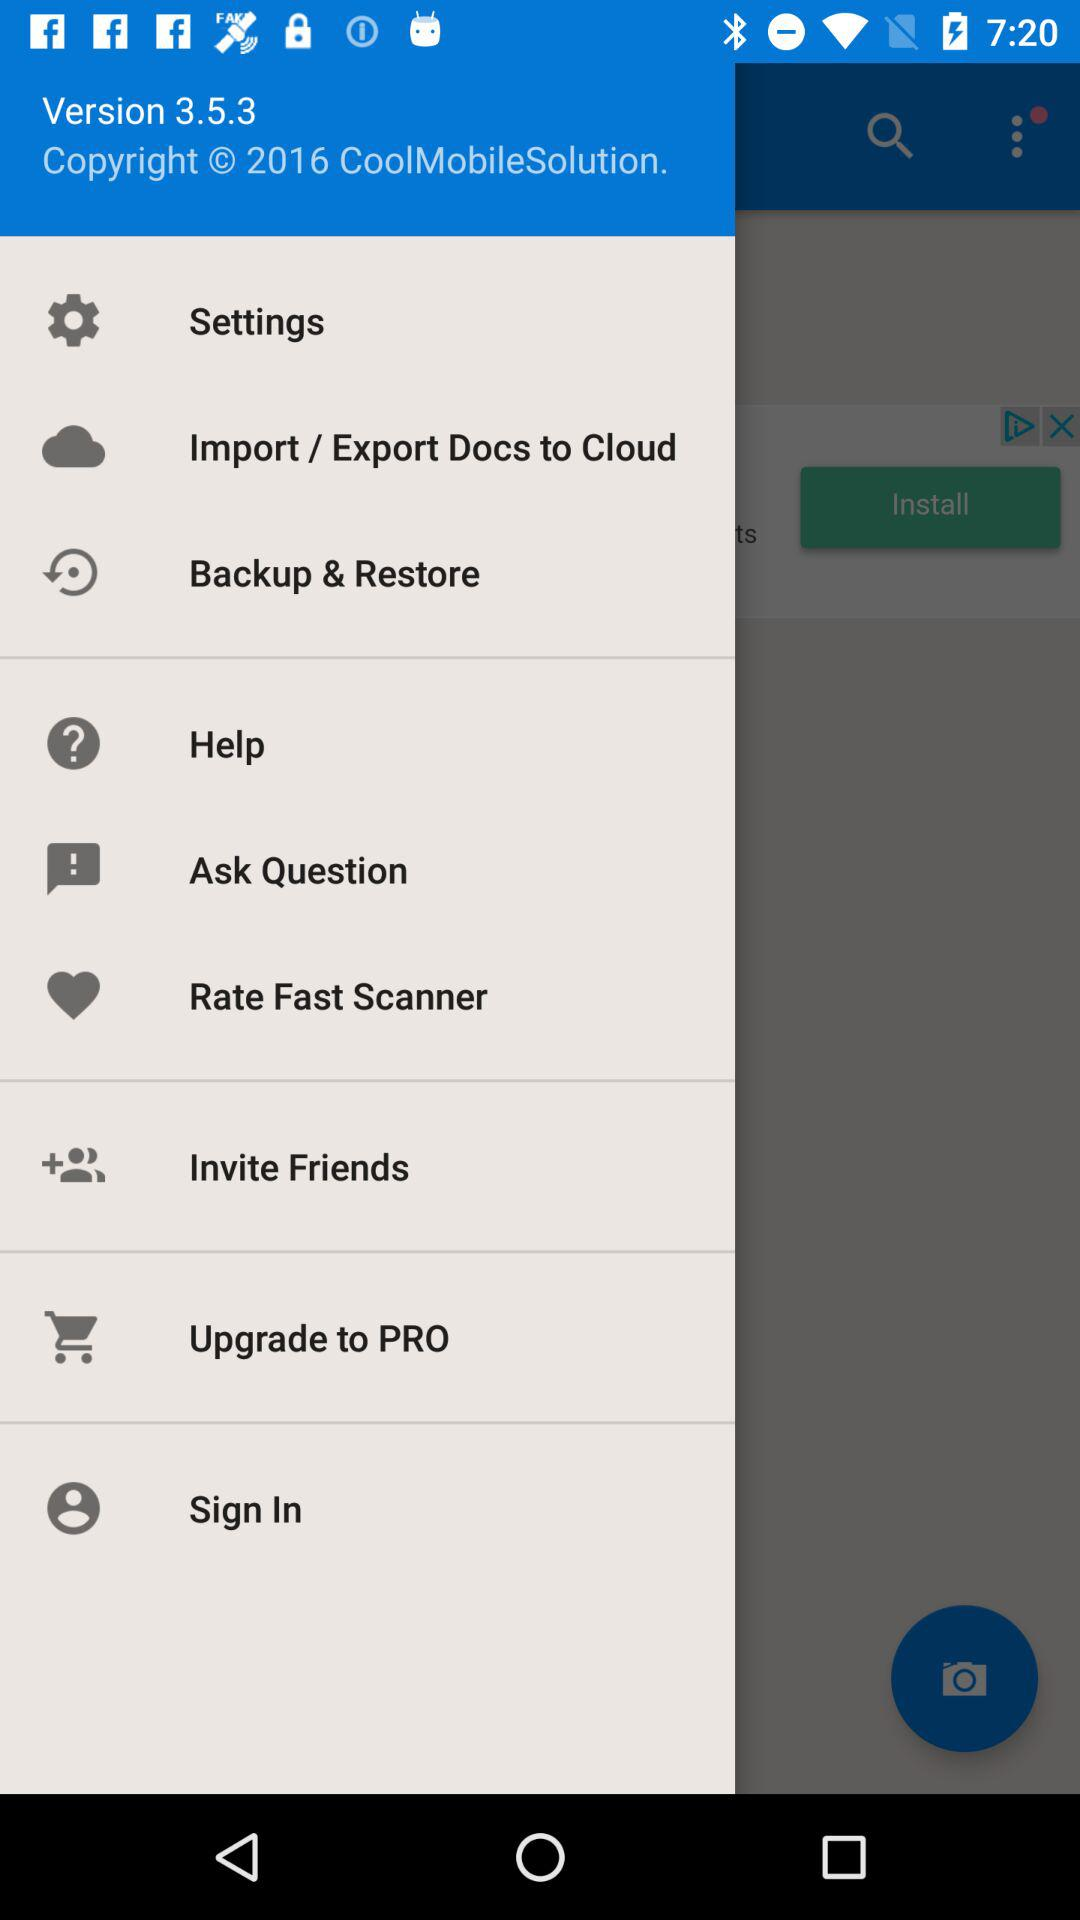What is the year of the copyright of "CoolMobileSolution"? The year of the copyright is 2016. 